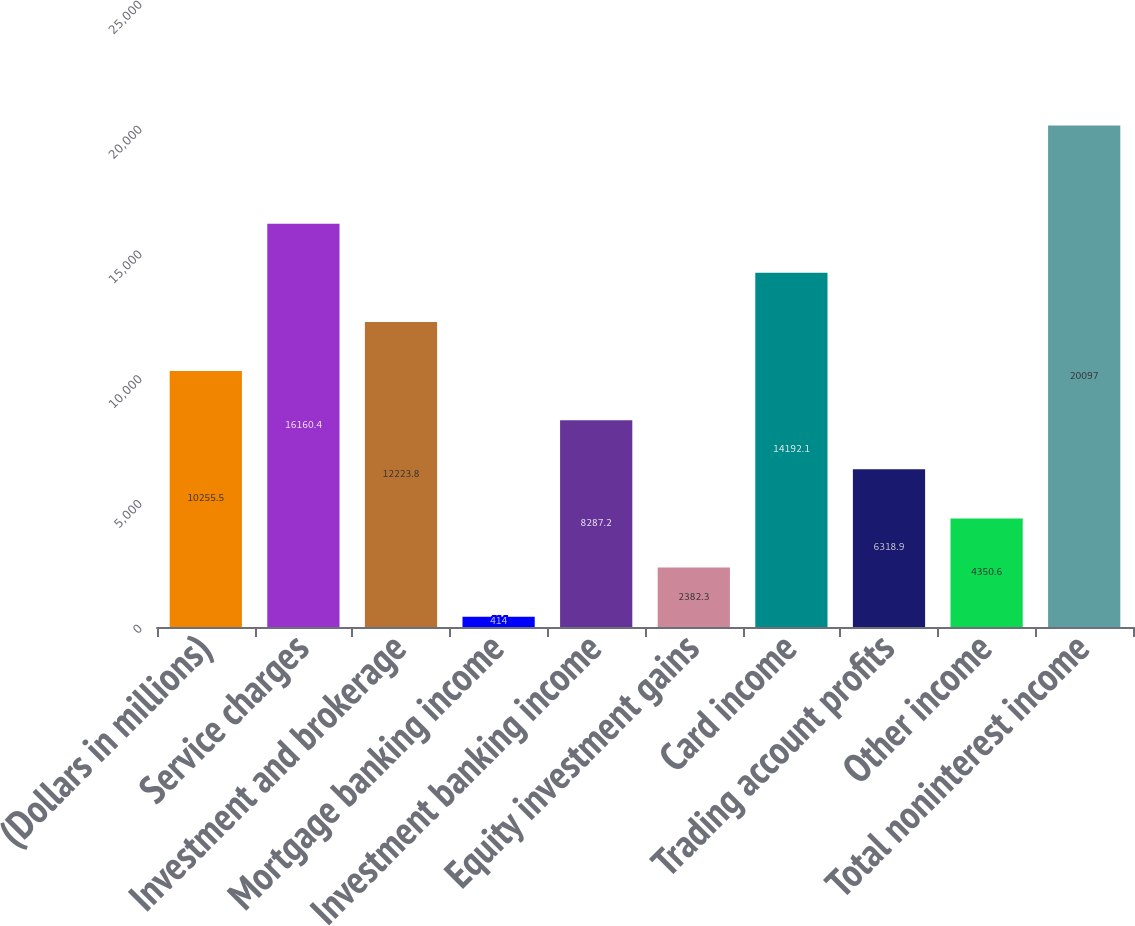<chart> <loc_0><loc_0><loc_500><loc_500><bar_chart><fcel>(Dollars in millions)<fcel>Service charges<fcel>Investment and brokerage<fcel>Mortgage banking income<fcel>Investment banking income<fcel>Equity investment gains<fcel>Card income<fcel>Trading account profits<fcel>Other income<fcel>Total noninterest income<nl><fcel>10255.5<fcel>16160.4<fcel>12223.8<fcel>414<fcel>8287.2<fcel>2382.3<fcel>14192.1<fcel>6318.9<fcel>4350.6<fcel>20097<nl></chart> 